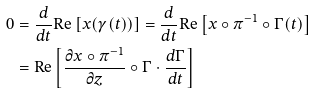<formula> <loc_0><loc_0><loc_500><loc_500>0 & = \frac { d } { d t } \text {Re} \left [ x ( \gamma ( t ) ) \right ] = \frac { d } { d t } \text {Re} \left [ x \circ \pi ^ { - 1 } \circ \Gamma ( t ) \right ] \\ & = \text {Re} \left [ \frac { \partial x \circ \pi ^ { - 1 } } { \partial z } \circ \Gamma \cdot \frac { d \Gamma } { d t } \right ]</formula> 